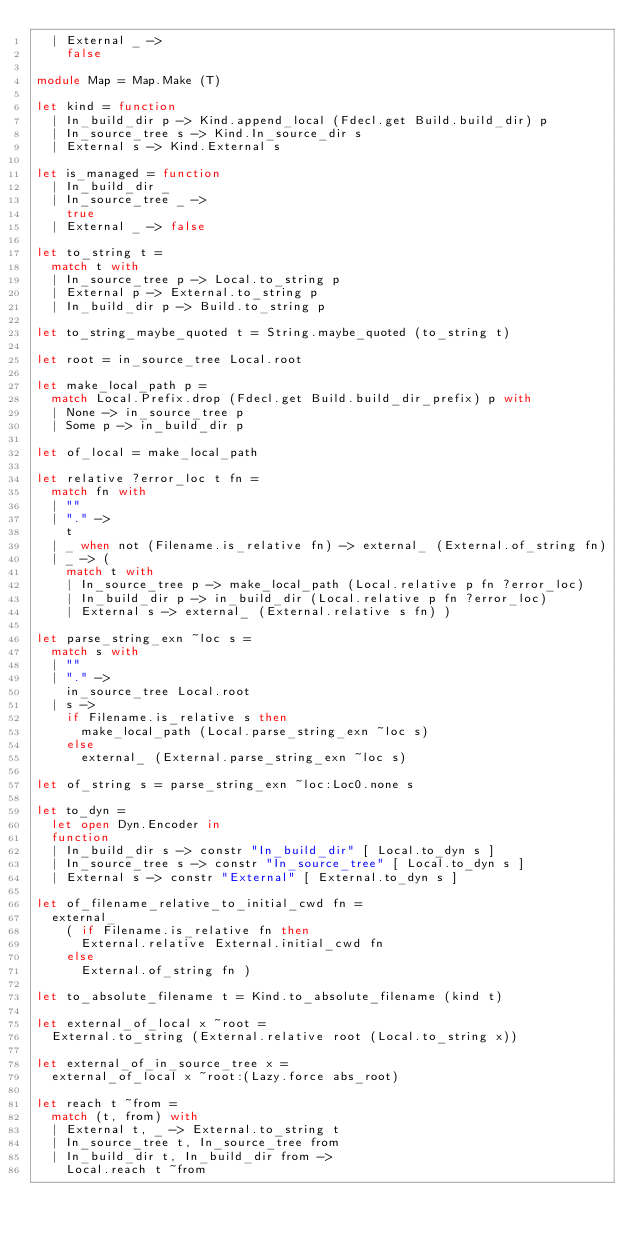<code> <loc_0><loc_0><loc_500><loc_500><_OCaml_>  | External _ ->
    false

module Map = Map.Make (T)

let kind = function
  | In_build_dir p -> Kind.append_local (Fdecl.get Build.build_dir) p
  | In_source_tree s -> Kind.In_source_dir s
  | External s -> Kind.External s

let is_managed = function
  | In_build_dir _
  | In_source_tree _ ->
    true
  | External _ -> false

let to_string t =
  match t with
  | In_source_tree p -> Local.to_string p
  | External p -> External.to_string p
  | In_build_dir p -> Build.to_string p

let to_string_maybe_quoted t = String.maybe_quoted (to_string t)

let root = in_source_tree Local.root

let make_local_path p =
  match Local.Prefix.drop (Fdecl.get Build.build_dir_prefix) p with
  | None -> in_source_tree p
  | Some p -> in_build_dir p

let of_local = make_local_path

let relative ?error_loc t fn =
  match fn with
  | ""
  | "." ->
    t
  | _ when not (Filename.is_relative fn) -> external_ (External.of_string fn)
  | _ -> (
    match t with
    | In_source_tree p -> make_local_path (Local.relative p fn ?error_loc)
    | In_build_dir p -> in_build_dir (Local.relative p fn ?error_loc)
    | External s -> external_ (External.relative s fn) )

let parse_string_exn ~loc s =
  match s with
  | ""
  | "." ->
    in_source_tree Local.root
  | s ->
    if Filename.is_relative s then
      make_local_path (Local.parse_string_exn ~loc s)
    else
      external_ (External.parse_string_exn ~loc s)

let of_string s = parse_string_exn ~loc:Loc0.none s

let to_dyn =
  let open Dyn.Encoder in
  function
  | In_build_dir s -> constr "In_build_dir" [ Local.to_dyn s ]
  | In_source_tree s -> constr "In_source_tree" [ Local.to_dyn s ]
  | External s -> constr "External" [ External.to_dyn s ]

let of_filename_relative_to_initial_cwd fn =
  external_
    ( if Filename.is_relative fn then
      External.relative External.initial_cwd fn
    else
      External.of_string fn )

let to_absolute_filename t = Kind.to_absolute_filename (kind t)

let external_of_local x ~root =
  External.to_string (External.relative root (Local.to_string x))

let external_of_in_source_tree x =
  external_of_local x ~root:(Lazy.force abs_root)

let reach t ~from =
  match (t, from) with
  | External t, _ -> External.to_string t
  | In_source_tree t, In_source_tree from
  | In_build_dir t, In_build_dir from ->
    Local.reach t ~from</code> 